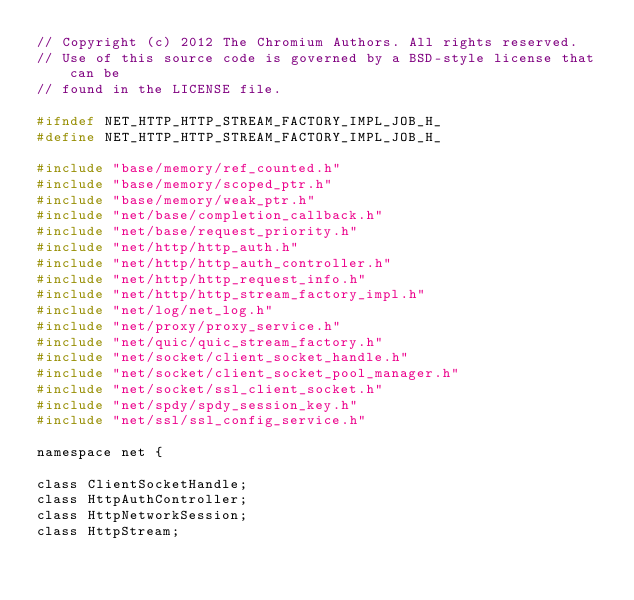Convert code to text. <code><loc_0><loc_0><loc_500><loc_500><_C_>// Copyright (c) 2012 The Chromium Authors. All rights reserved.
// Use of this source code is governed by a BSD-style license that can be
// found in the LICENSE file.

#ifndef NET_HTTP_HTTP_STREAM_FACTORY_IMPL_JOB_H_
#define NET_HTTP_HTTP_STREAM_FACTORY_IMPL_JOB_H_

#include "base/memory/ref_counted.h"
#include "base/memory/scoped_ptr.h"
#include "base/memory/weak_ptr.h"
#include "net/base/completion_callback.h"
#include "net/base/request_priority.h"
#include "net/http/http_auth.h"
#include "net/http/http_auth_controller.h"
#include "net/http/http_request_info.h"
#include "net/http/http_stream_factory_impl.h"
#include "net/log/net_log.h"
#include "net/proxy/proxy_service.h"
#include "net/quic/quic_stream_factory.h"
#include "net/socket/client_socket_handle.h"
#include "net/socket/client_socket_pool_manager.h"
#include "net/socket/ssl_client_socket.h"
#include "net/spdy/spdy_session_key.h"
#include "net/ssl/ssl_config_service.h"

namespace net {

class ClientSocketHandle;
class HttpAuthController;
class HttpNetworkSession;
class HttpStream;</code> 